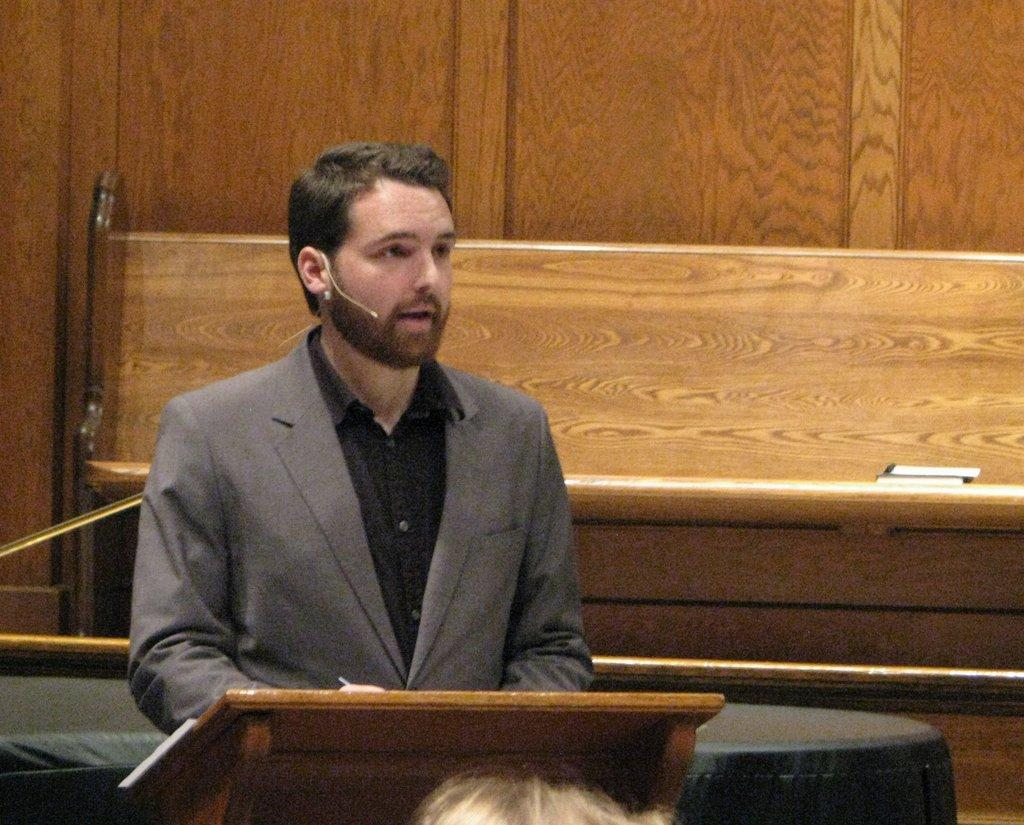What is the main subject of the image? There is a person in the image. What is the person wearing? The person is wearing a suit. What is the person doing in the image? The person is standing and speaking into a microphone. What is in front of the person? There is a wooden stand in front of the person. What can be seen in the background of the image? There are other objects in the background of the image. What decision is the person making in the image? There is no indication in the image that the person is making a decision. The person is speaking into a microphone, but their actions or intentions are not clear enough to determine if they are making a decision. 